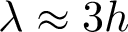<formula> <loc_0><loc_0><loc_500><loc_500>\lambda \approx 3 h</formula> 